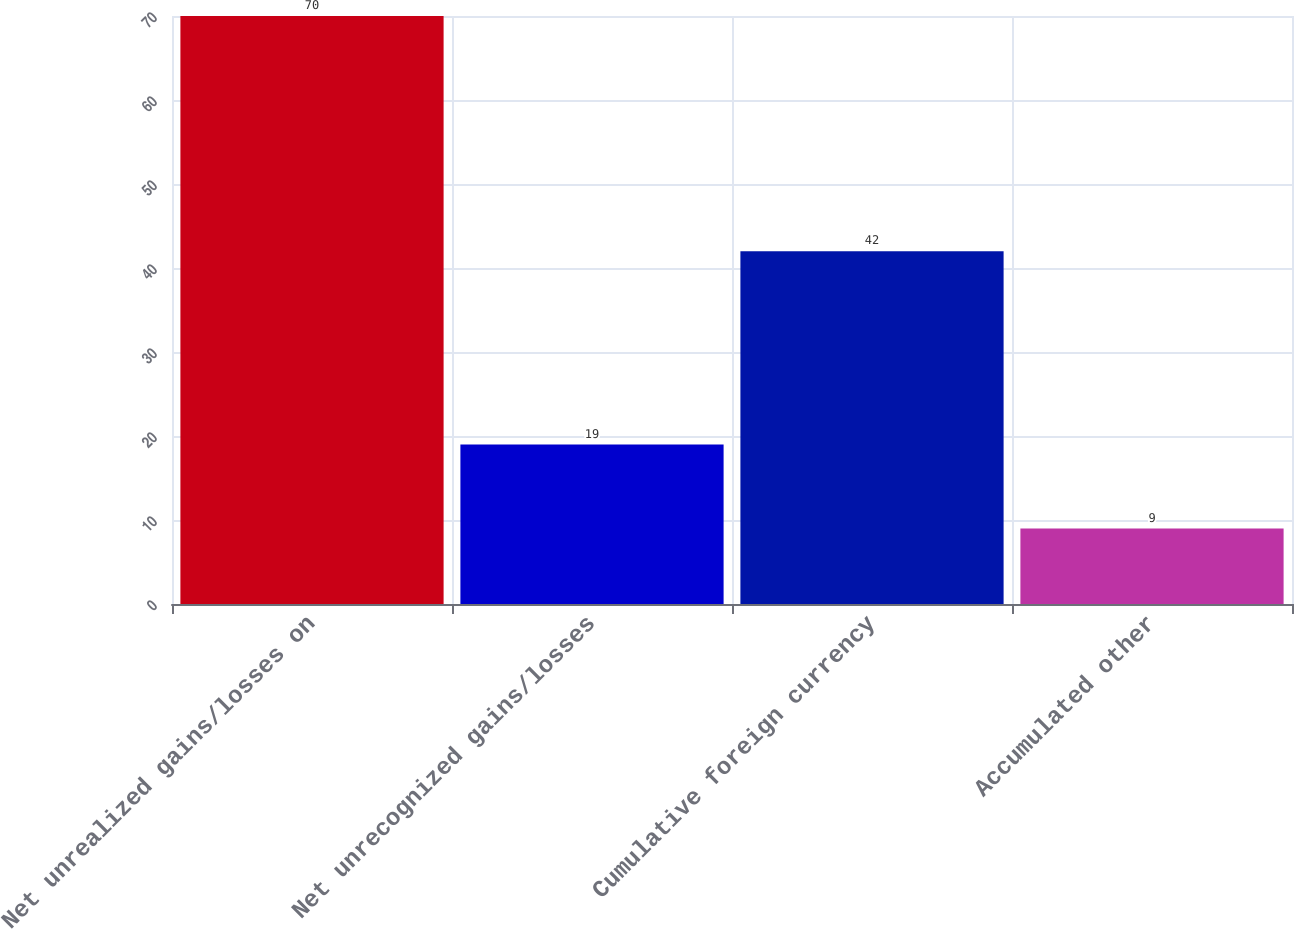Convert chart to OTSL. <chart><loc_0><loc_0><loc_500><loc_500><bar_chart><fcel>Net unrealized gains/losses on<fcel>Net unrecognized gains/losses<fcel>Cumulative foreign currency<fcel>Accumulated other<nl><fcel>70<fcel>19<fcel>42<fcel>9<nl></chart> 